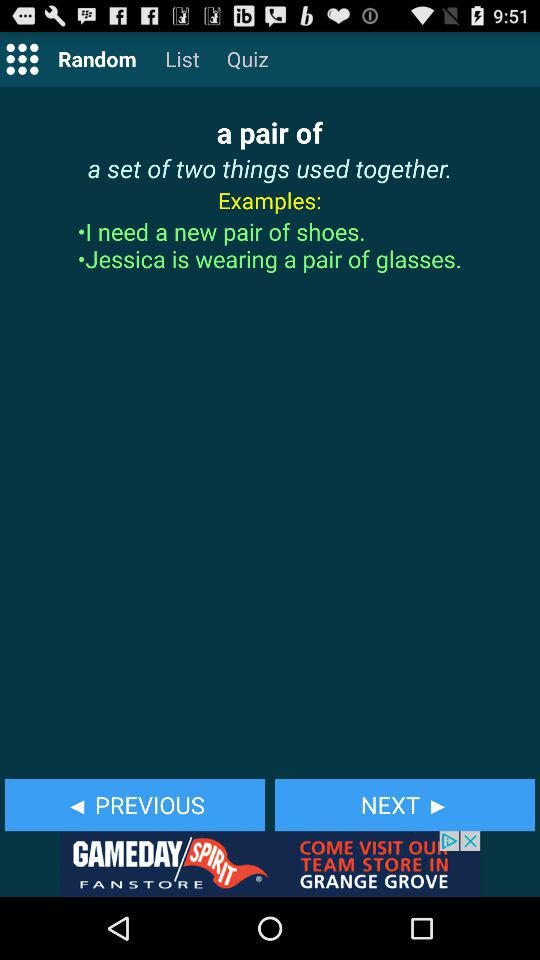How many examples are there?
Answer the question using a single word or phrase. 2 